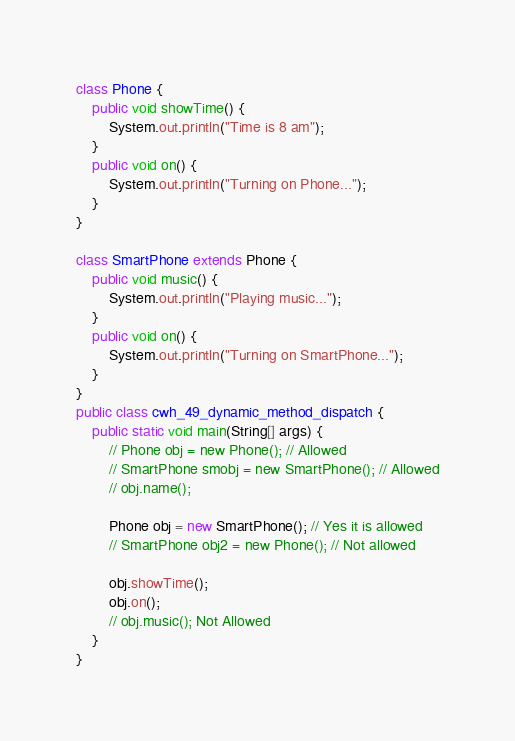Convert code to text. <code><loc_0><loc_0><loc_500><loc_500><_Java_>class Phone {
    public void showTime() {
        System.out.println("Time is 8 am");
    }
    public void on() {
        System.out.println("Turning on Phone...");
    }
}

class SmartPhone extends Phone {
    public void music() {
        System.out.println("Playing music...");
    }
    public void on() {
        System.out.println("Turning on SmartPhone...");
    }
}
public class cwh_49_dynamic_method_dispatch {
    public static void main(String[] args) {
        // Phone obj = new Phone(); // Allowed
        // SmartPhone smobj = new SmartPhone(); // Allowed
        // obj.name();

        Phone obj = new SmartPhone(); // Yes it is allowed
        // SmartPhone obj2 = new Phone(); // Not allowed

        obj.showTime();
        obj.on();
        // obj.music(); Not Allowed
    }
}
</code> 